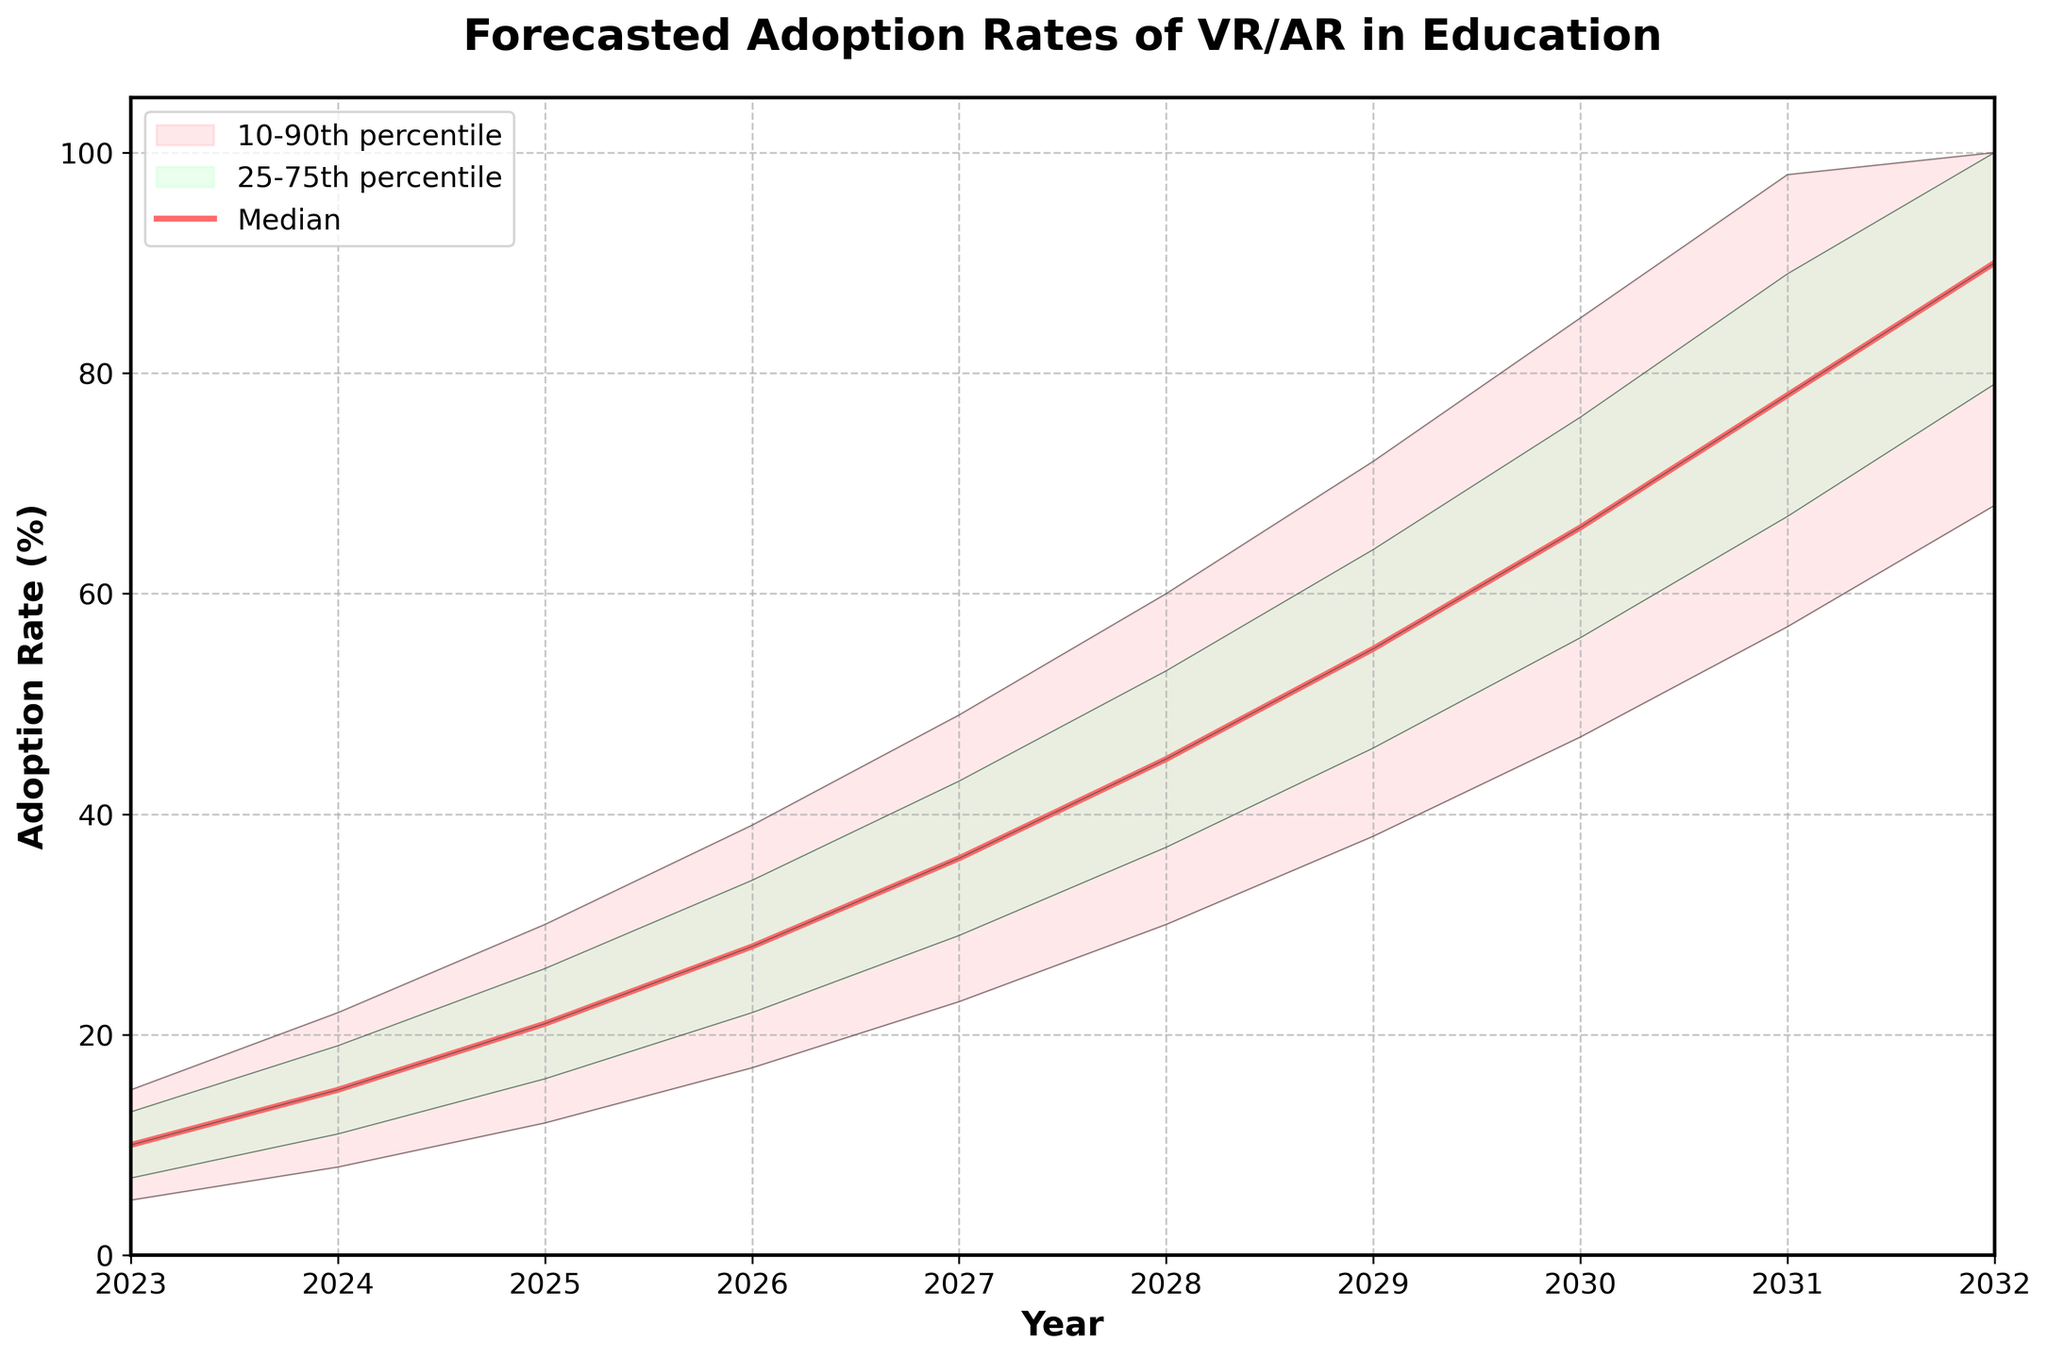What is the title of the chart? The title of the chart is written at the top of the figure and it reads "Forecasted Adoption Rates of VR/AR in Education".
Answer: Forecasted Adoption Rates of VR/AR in Education What is the median adoption rate for the year 2026? The median adoption rate is represented by the line labeled "Median," which is highlighted in the middle of the chart. For the year 2026, follow this line vertically up to the value axis. The value at this intersection is 28%.
Answer: 28% What years does the forecast data cover? The x-axis represents the years. By looking at the first and last points on the x-axis, we can see that the forecast data covers from 2023 to 2032.
Answer: 2023 to 2032 What is the adoption rate range (P10 to P90) for the year 2029? The range between P10 and P90 is shown by the shaded area. For the year 2029, the values at P10 and P90 can be found by looking vertically at these respective lines. The adoption rate spans from 38% (P10) to 72% (P90).
Answer: 38% to 72% Is the expected growth in adoption rates faster in the first five years or the last five years? To determine the rate of growth, we compare the difference in adoption rates at median (P50) for the first five years (2023-2027) and the last five years (2028-2032). For 2023-2027, the median grows from 10% to 36% (a difference of 26%). For 2028-2032, it grows from 45% to 90% (a difference of 45%). Therefore, the growth is faster in the last five years.
Answer: Last five years What is the difference in the 75th percentile adoption rate between 2023 and 2032? To find the difference, locate the 75th percentile for both years and subtract the earlier value from the later value. For 2023, the 75th percentile is 13%, and for 2032 it is 100%. The difference is 100% - 13% = 87%.
Answer: 87% In 2024, how much higher is the P75 adoption rate compared to the P25 rate? To compare the two percentiles, identify the values at P75 and P25 for the year 2024. The P75 rate is 19%, and the P25 rate is 11%. The difference is 19% - 11% = 8%.
Answer: 8% Which year has the highest interquartile range (IQR), and what is its value? The IQR is found by subtracting P25 from P75 for each year. Calculate the IQR for each year, and identify the highest value. For simplicity, the highest IQR observed is in 2031 with P75 at 89% and P25 at 67%. The IQR is 89% - 67% = 22%.
Answer: 2031, 22% 